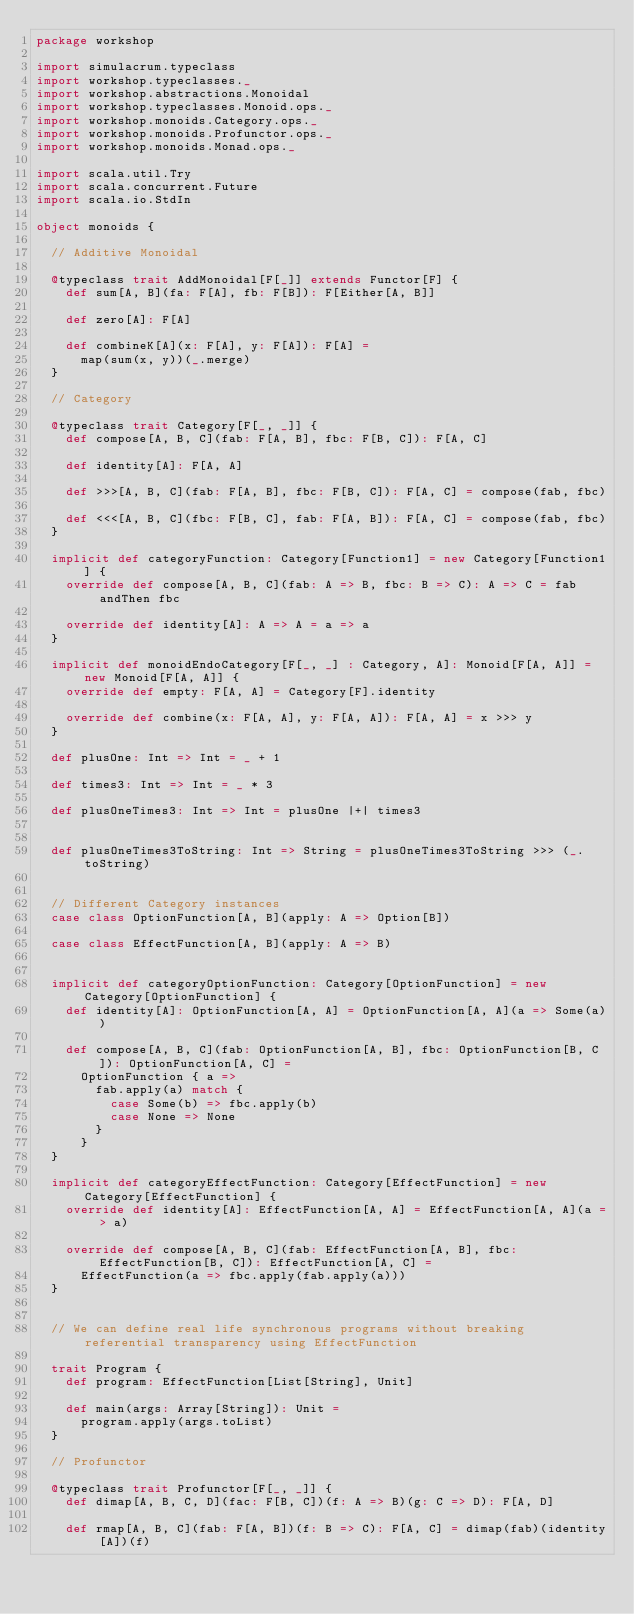Convert code to text. <code><loc_0><loc_0><loc_500><loc_500><_Scala_>package workshop

import simulacrum.typeclass
import workshop.typeclasses._
import workshop.abstractions.Monoidal
import workshop.typeclasses.Monoid.ops._
import workshop.monoids.Category.ops._
import workshop.monoids.Profunctor.ops._
import workshop.monoids.Monad.ops._

import scala.util.Try
import scala.concurrent.Future
import scala.io.StdIn

object monoids {

  // Additive Monoidal

  @typeclass trait AddMonoidal[F[_]] extends Functor[F] {
    def sum[A, B](fa: F[A], fb: F[B]): F[Either[A, B]]

    def zero[A]: F[A]

    def combineK[A](x: F[A], y: F[A]): F[A] =
      map(sum(x, y))(_.merge)
  }

  // Category

  @typeclass trait Category[F[_, _]] {
    def compose[A, B, C](fab: F[A, B], fbc: F[B, C]): F[A, C]

    def identity[A]: F[A, A]

    def >>>[A, B, C](fab: F[A, B], fbc: F[B, C]): F[A, C] = compose(fab, fbc)

    def <<<[A, B, C](fbc: F[B, C], fab: F[A, B]): F[A, C] = compose(fab, fbc)
  }

  implicit def categoryFunction: Category[Function1] = new Category[Function1] {
    override def compose[A, B, C](fab: A => B, fbc: B => C): A => C = fab andThen fbc

    override def identity[A]: A => A = a => a
  }

  implicit def monoidEndoCategory[F[_, _] : Category, A]: Monoid[F[A, A]] = new Monoid[F[A, A]] {
    override def empty: F[A, A] = Category[F].identity

    override def combine(x: F[A, A], y: F[A, A]): F[A, A] = x >>> y
  }

  def plusOne: Int => Int = _ + 1

  def times3: Int => Int = _ * 3

  def plusOneTimes3: Int => Int = plusOne |+| times3


  def plusOneTimes3ToString: Int => String = plusOneTimes3ToString >>> (_.toString)


  // Different Category instances
  case class OptionFunction[A, B](apply: A => Option[B])

  case class EffectFunction[A, B](apply: A => B)


  implicit def categoryOptionFunction: Category[OptionFunction] = new Category[OptionFunction] {
    def identity[A]: OptionFunction[A, A] = OptionFunction[A, A](a => Some(a))

    def compose[A, B, C](fab: OptionFunction[A, B], fbc: OptionFunction[B, C]): OptionFunction[A, C] =
      OptionFunction { a =>
        fab.apply(a) match {
          case Some(b) => fbc.apply(b)
          case None => None
        }
      }
  }

  implicit def categoryEffectFunction: Category[EffectFunction] = new Category[EffectFunction] {
    override def identity[A]: EffectFunction[A, A] = EffectFunction[A, A](a => a)

    override def compose[A, B, C](fab: EffectFunction[A, B], fbc: EffectFunction[B, C]): EffectFunction[A, C] =
      EffectFunction(a => fbc.apply(fab.apply(a)))
  }


  // We can define real life synchronous programs without breaking referential transparency using EffectFunction

  trait Program {
    def program: EffectFunction[List[String], Unit]

    def main(args: Array[String]): Unit =
      program.apply(args.toList)
  }

  // Profunctor

  @typeclass trait Profunctor[F[_, _]] {
    def dimap[A, B, C, D](fac: F[B, C])(f: A => B)(g: C => D): F[A, D]

    def rmap[A, B, C](fab: F[A, B])(f: B => C): F[A, C] = dimap(fab)(identity[A])(f)
</code> 